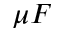<formula> <loc_0><loc_0><loc_500><loc_500>\mu F</formula> 